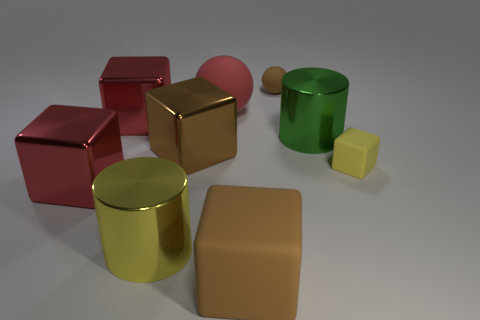Subtract all brown metallic cubes. How many cubes are left? 4 Subtract 1 cubes. How many cubes are left? 4 Subtract all red blocks. How many blocks are left? 3 Subtract all cyan cylinders. Subtract all green blocks. How many cylinders are left? 2 Subtract all blue cylinders. How many green spheres are left? 0 Subtract all red balls. Subtract all shiny cylinders. How many objects are left? 6 Add 4 large red blocks. How many large red blocks are left? 6 Add 5 yellow cubes. How many yellow cubes exist? 6 Subtract 1 brown spheres. How many objects are left? 8 Subtract all spheres. How many objects are left? 7 